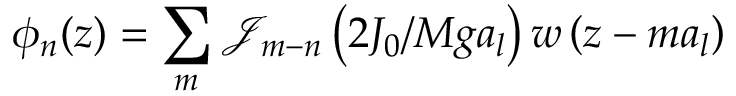Convert formula to latex. <formula><loc_0><loc_0><loc_500><loc_500>\phi _ { n } ( z ) = \sum _ { m } \mathcal { J } _ { m - n } \left ( 2 J _ { 0 } / M g a _ { l } \right ) w \left ( z - m a _ { l } \right )</formula> 